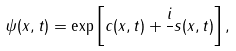<formula> <loc_0><loc_0><loc_500><loc_500>\psi ( x , t ) = \exp \left [ c ( x , t ) + \frac { i } { } s ( x , t ) \right ] ,</formula> 